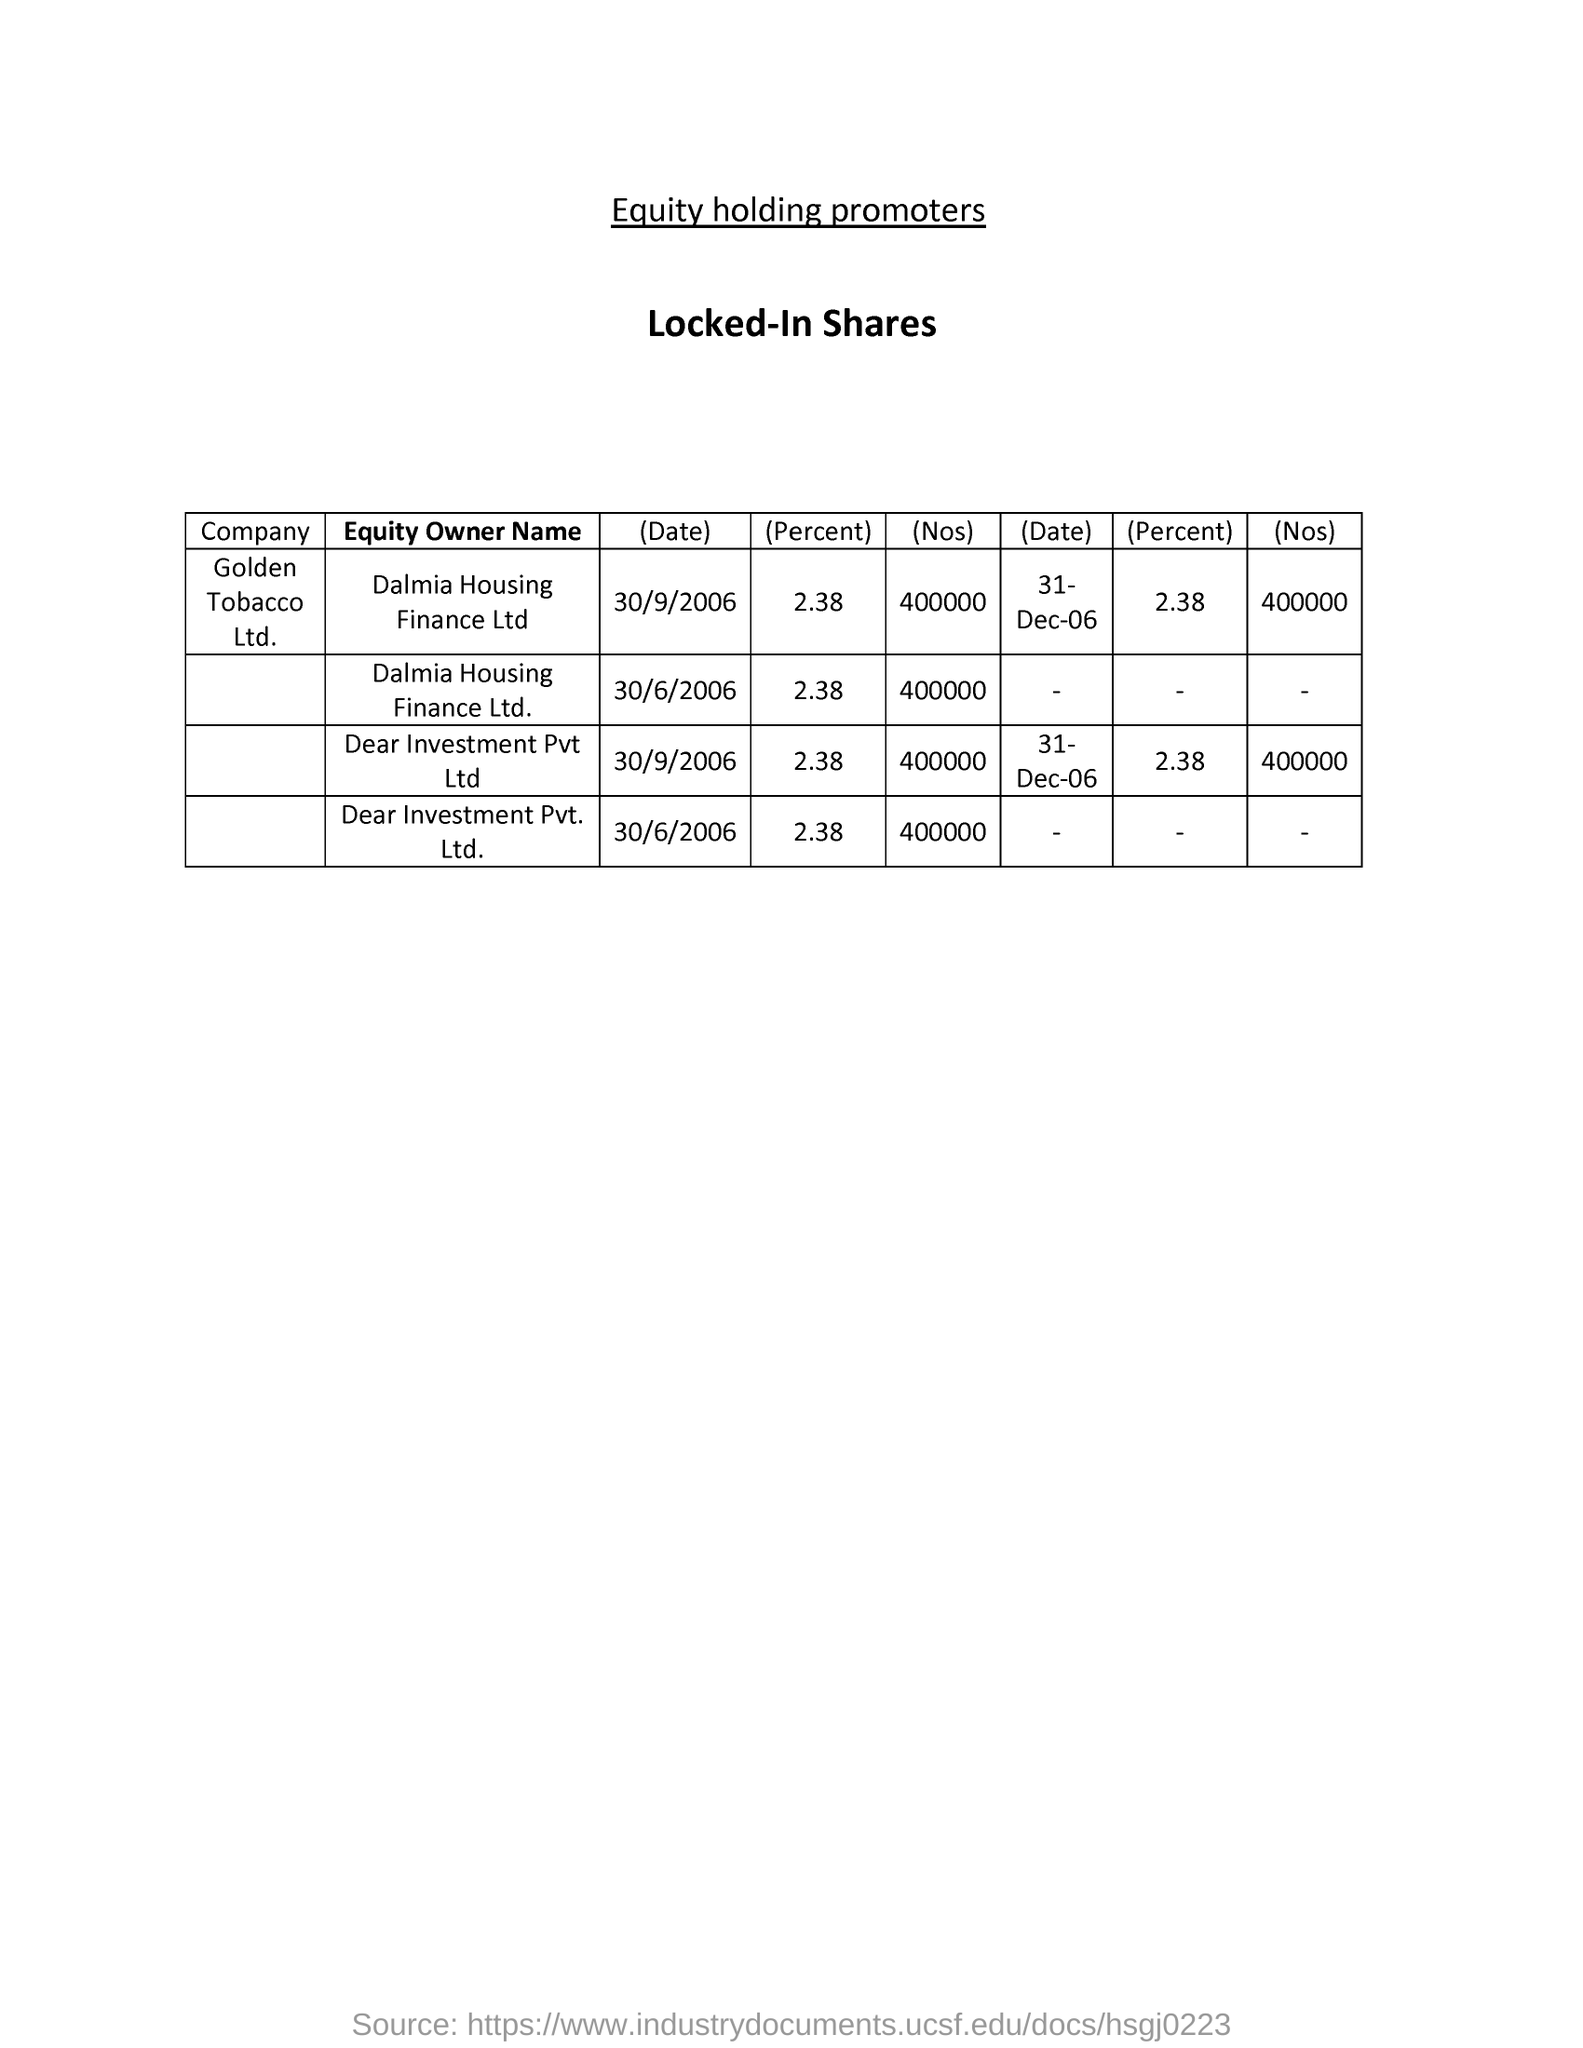What type of shares are mentioned?
Ensure brevity in your answer.  Locked-In shares. 